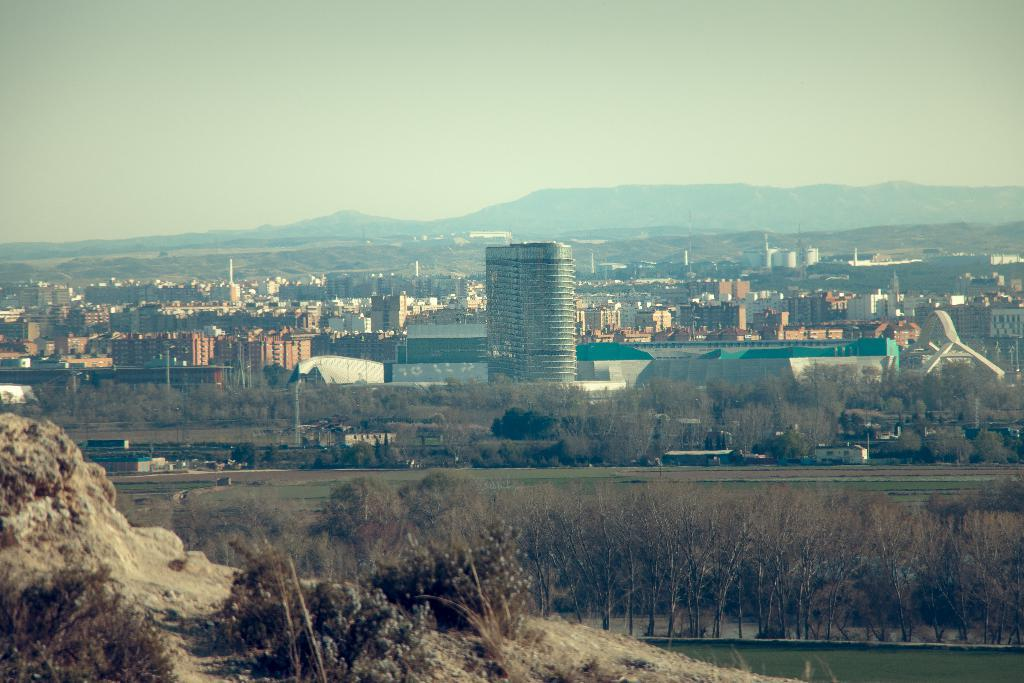What type of structures can be seen in the image? There are buildings in the image. What else can be seen in the image besides buildings? There are poles, trees, plants, grass, and mud visible in the image. What is the natural environment like in the image? The natural environment includes trees, plants, grass, and mud. What part of the sky is visible in the image? The sky is visible in the image. What type of vein is visible in the image? There is no vein present in the image. What type of protest is taking place in the image? There is no protest present in the image. 